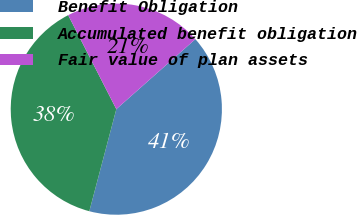<chart> <loc_0><loc_0><loc_500><loc_500><pie_chart><fcel>Benefit Obligation<fcel>Accumulated benefit obligation<fcel>Fair value of plan assets<nl><fcel>40.65%<fcel>38.35%<fcel>21.0%<nl></chart> 